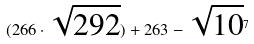Convert formula to latex. <formula><loc_0><loc_0><loc_500><loc_500>( 2 6 6 \cdot \sqrt { 2 9 2 } ) + 2 6 3 - \sqrt { 1 0 } ^ { 7 }</formula> 